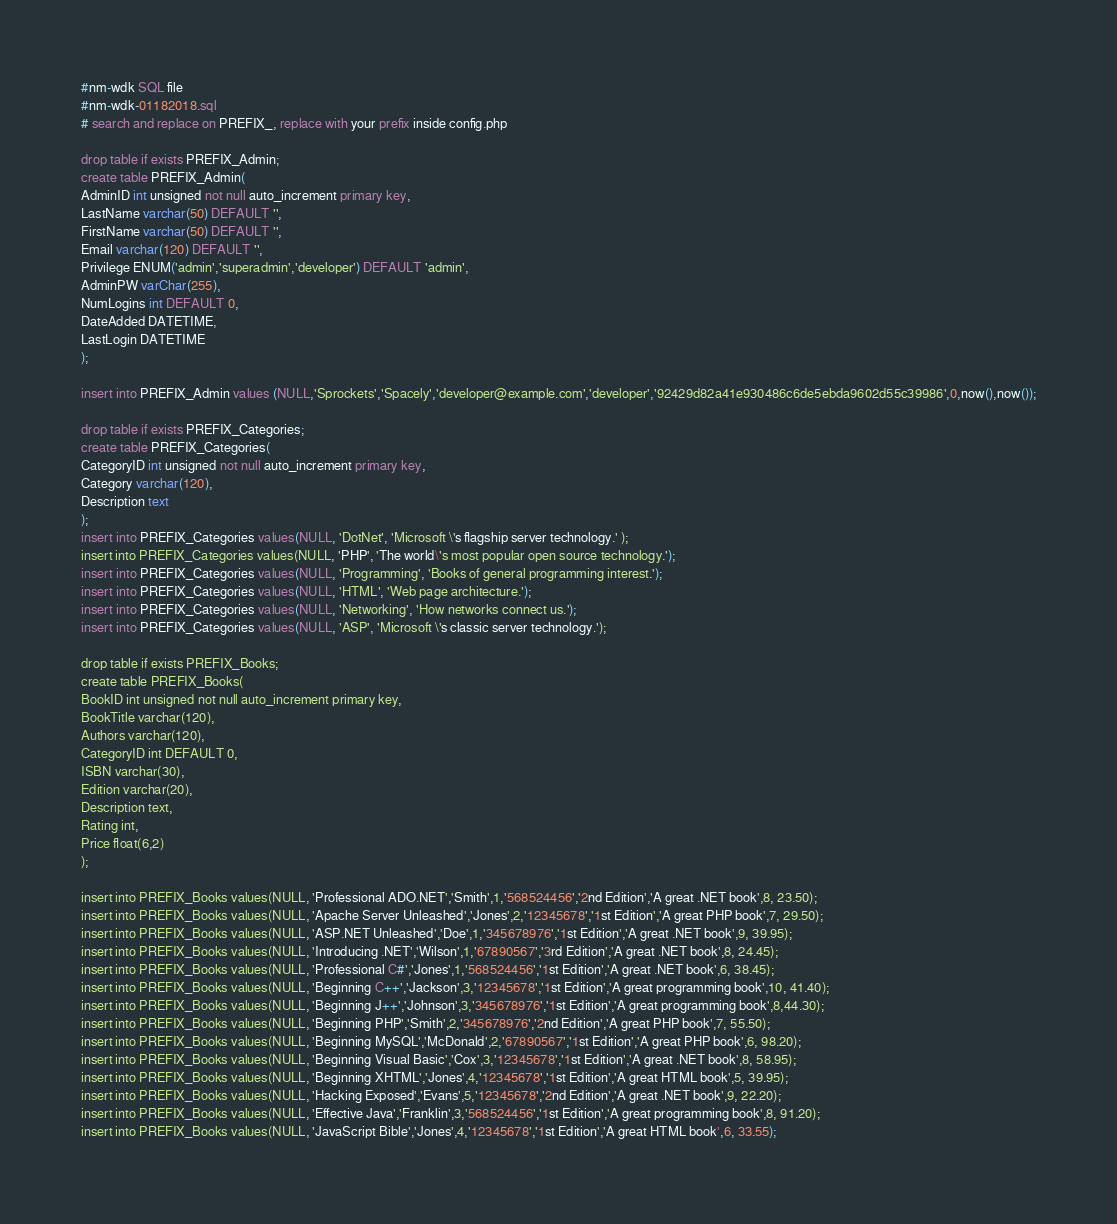<code> <loc_0><loc_0><loc_500><loc_500><_SQL_>#nm-wdk SQL file
#nm-wdk-01182018.sql
# search and replace on PREFIX_, replace with your prefix inside config.php 

drop table if exists PREFIX_Admin;
create table PREFIX_Admin(
AdminID int unsigned not null auto_increment primary key,
LastName varchar(50) DEFAULT '',
FirstName varchar(50) DEFAULT '',
Email varchar(120) DEFAULT '',
Privilege ENUM('admin','superadmin','developer') DEFAULT 'admin',
AdminPW varChar(255),
NumLogins int DEFAULT 0,
DateAdded DATETIME,
LastLogin DATETIME
);

insert into PREFIX_Admin values (NULL,'Sprockets','Spacely','developer@example.com','developer','92429d82a41e930486c6de5ebda9602d55c39986',0,now(),now());

drop table if exists PREFIX_Categories;
create table PREFIX_Categories(
CategoryID int unsigned not null auto_increment primary key,
Category varchar(120),
Description text
);
insert into PREFIX_Categories values(NULL, 'DotNet', 'Microsoft \'s flagship server technology.' );
insert into PREFIX_Categories values(NULL, 'PHP', 'The world\'s most popular open source technology.');
insert into PREFIX_Categories values(NULL, 'Programming', 'Books of general programming interest.');
insert into PREFIX_Categories values(NULL, 'HTML', 'Web page architecture.');
insert into PREFIX_Categories values(NULL, 'Networking', 'How networks connect us.');
insert into PREFIX_Categories values(NULL, 'ASP', 'Microsoft \'s classic server technology.');

drop table if exists PREFIX_Books;
create table PREFIX_Books(
BookID int unsigned not null auto_increment primary key,
BookTitle varchar(120),
Authors varchar(120),
CategoryID int DEFAULT 0,
ISBN varchar(30),
Edition varchar(20),
Description text,
Rating int,
Price float(6,2)
); 

insert into PREFIX_Books values(NULL, 'Professional ADO.NET','Smith',1,'568524456','2nd Edition','A great .NET book',8, 23.50);
insert into PREFIX_Books values(NULL, 'Apache Server Unleashed','Jones',2,'12345678','1st Edition','A great PHP book',7, 29.50);
insert into PREFIX_Books values(NULL, 'ASP.NET Unleashed','Doe',1,'345678976','1st Edition','A great .NET book',9, 39.95);
insert into PREFIX_Books values(NULL, 'Introducing .NET','Wilson',1,'67890567','3rd Edition','A great .NET book',8, 24.45);
insert into PREFIX_Books values(NULL, 'Professional C#','Jones',1,'568524456','1st Edition','A great .NET book',6, 38.45);
insert into PREFIX_Books values(NULL, 'Beginning C++','Jackson',3,'12345678','1st Edition','A great programming book',10, 41.40);
insert into PREFIX_Books values(NULL, 'Beginning J++','Johnson',3,'345678976','1st Edition','A great programming book',8,44.30);
insert into PREFIX_Books values(NULL, 'Beginning PHP','Smith',2,'345678976','2nd Edition','A great PHP book',7, 55.50);
insert into PREFIX_Books values(NULL, 'Beginning MySQL','McDonald',2,'67890567','1st Edition','A great PHP book',6, 98.20);
insert into PREFIX_Books values(NULL, 'Beginning Visual Basic','Cox',3,'12345678','1st Edition','A great .NET book',8, 58.95);
insert into PREFIX_Books values(NULL, 'Beginning XHTML','Jones',4,'12345678','1st Edition','A great HTML book',5, 39.95);
insert into PREFIX_Books values(NULL, 'Hacking Exposed','Evans',5,'12345678','2nd Edition','A great .NET book',9, 22.20);
insert into PREFIX_Books values(NULL, 'Effective Java','Franklin',3,'568524456','1st Edition','A great programming book',8, 91.20);
insert into PREFIX_Books values(NULL, 'JavaScript Bible','Jones',4,'12345678','1st Edition','A great HTML book',6, 33.55);</code> 